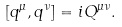<formula> <loc_0><loc_0><loc_500><loc_500>[ q ^ { \mu } , q ^ { \nu } ] = i Q ^ { \mu \nu } .</formula> 